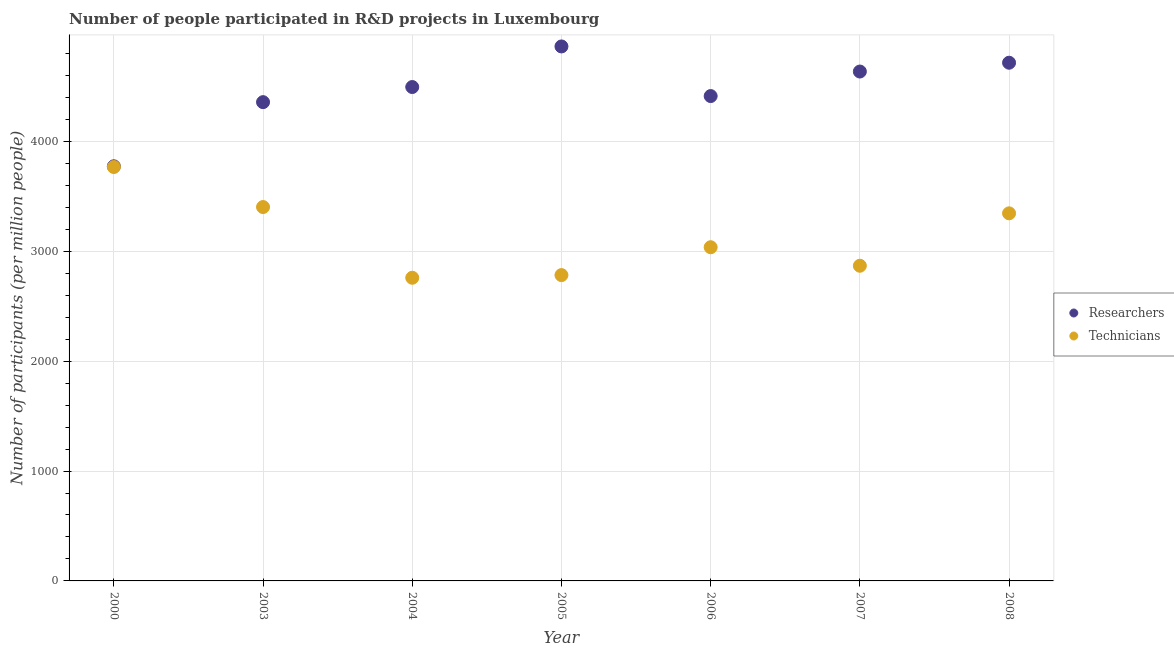What is the number of technicians in 2003?
Provide a short and direct response. 3402.45. Across all years, what is the maximum number of technicians?
Give a very brief answer. 3766.87. Across all years, what is the minimum number of technicians?
Your answer should be compact. 2758.91. In which year was the number of researchers minimum?
Your answer should be very brief. 2000. What is the total number of researchers in the graph?
Provide a short and direct response. 3.13e+04. What is the difference between the number of technicians in 2003 and that in 2008?
Provide a short and direct response. 57.23. What is the difference between the number of technicians in 2004 and the number of researchers in 2008?
Your answer should be very brief. -1957.02. What is the average number of researchers per year?
Offer a very short reply. 4464.75. In the year 2006, what is the difference between the number of researchers and number of technicians?
Keep it short and to the point. 1375.63. In how many years, is the number of researchers greater than 1800?
Provide a succinct answer. 7. What is the ratio of the number of technicians in 2004 to that in 2008?
Ensure brevity in your answer.  0.82. Is the difference between the number of researchers in 2003 and 2007 greater than the difference between the number of technicians in 2003 and 2007?
Provide a short and direct response. No. What is the difference between the highest and the second highest number of technicians?
Offer a very short reply. 364.42. What is the difference between the highest and the lowest number of technicians?
Offer a terse response. 1007.96. Is the sum of the number of researchers in 2003 and 2007 greater than the maximum number of technicians across all years?
Provide a short and direct response. Yes. Does the number of technicians monotonically increase over the years?
Provide a short and direct response. No. How many years are there in the graph?
Your answer should be compact. 7. What is the difference between two consecutive major ticks on the Y-axis?
Provide a succinct answer. 1000. Are the values on the major ticks of Y-axis written in scientific E-notation?
Give a very brief answer. No. Does the graph contain grids?
Provide a short and direct response. Yes. What is the title of the graph?
Your answer should be very brief. Number of people participated in R&D projects in Luxembourg. What is the label or title of the Y-axis?
Offer a very short reply. Number of participants (per million people). What is the Number of participants (per million people) of Researchers in 2000?
Provide a short and direct response. 3773.39. What is the Number of participants (per million people) in Technicians in 2000?
Your response must be concise. 3766.87. What is the Number of participants (per million people) of Researchers in 2003?
Your answer should be compact. 4357.05. What is the Number of participants (per million people) of Technicians in 2003?
Provide a short and direct response. 3402.45. What is the Number of participants (per million people) in Researchers in 2004?
Make the answer very short. 4494.65. What is the Number of participants (per million people) of Technicians in 2004?
Provide a succinct answer. 2758.91. What is the Number of participants (per million people) in Researchers in 2005?
Keep it short and to the point. 4864.07. What is the Number of participants (per million people) in Technicians in 2005?
Offer a very short reply. 2783.2. What is the Number of participants (per million people) in Researchers in 2006?
Provide a succinct answer. 4412.45. What is the Number of participants (per million people) in Technicians in 2006?
Ensure brevity in your answer.  3036.82. What is the Number of participants (per million people) in Researchers in 2007?
Keep it short and to the point. 4635.72. What is the Number of participants (per million people) in Technicians in 2007?
Your answer should be compact. 2868.27. What is the Number of participants (per million people) in Researchers in 2008?
Ensure brevity in your answer.  4715.93. What is the Number of participants (per million people) in Technicians in 2008?
Your answer should be very brief. 3345.22. Across all years, what is the maximum Number of participants (per million people) in Researchers?
Your answer should be very brief. 4864.07. Across all years, what is the maximum Number of participants (per million people) in Technicians?
Offer a very short reply. 3766.87. Across all years, what is the minimum Number of participants (per million people) in Researchers?
Ensure brevity in your answer.  3773.39. Across all years, what is the minimum Number of participants (per million people) of Technicians?
Offer a terse response. 2758.91. What is the total Number of participants (per million people) in Researchers in the graph?
Offer a terse response. 3.13e+04. What is the total Number of participants (per million people) in Technicians in the graph?
Give a very brief answer. 2.20e+04. What is the difference between the Number of participants (per million people) in Researchers in 2000 and that in 2003?
Provide a short and direct response. -583.66. What is the difference between the Number of participants (per million people) of Technicians in 2000 and that in 2003?
Ensure brevity in your answer.  364.42. What is the difference between the Number of participants (per million people) in Researchers in 2000 and that in 2004?
Give a very brief answer. -721.26. What is the difference between the Number of participants (per million people) in Technicians in 2000 and that in 2004?
Give a very brief answer. 1007.96. What is the difference between the Number of participants (per million people) of Researchers in 2000 and that in 2005?
Your answer should be compact. -1090.68. What is the difference between the Number of participants (per million people) of Technicians in 2000 and that in 2005?
Your answer should be compact. 983.67. What is the difference between the Number of participants (per million people) of Researchers in 2000 and that in 2006?
Provide a short and direct response. -639.07. What is the difference between the Number of participants (per million people) of Technicians in 2000 and that in 2006?
Make the answer very short. 730.04. What is the difference between the Number of participants (per million people) in Researchers in 2000 and that in 2007?
Ensure brevity in your answer.  -862.34. What is the difference between the Number of participants (per million people) in Technicians in 2000 and that in 2007?
Your answer should be compact. 898.6. What is the difference between the Number of participants (per million people) of Researchers in 2000 and that in 2008?
Your answer should be compact. -942.55. What is the difference between the Number of participants (per million people) in Technicians in 2000 and that in 2008?
Ensure brevity in your answer.  421.65. What is the difference between the Number of participants (per million people) in Researchers in 2003 and that in 2004?
Keep it short and to the point. -137.6. What is the difference between the Number of participants (per million people) in Technicians in 2003 and that in 2004?
Give a very brief answer. 643.54. What is the difference between the Number of participants (per million people) of Researchers in 2003 and that in 2005?
Make the answer very short. -507.02. What is the difference between the Number of participants (per million people) in Technicians in 2003 and that in 2005?
Ensure brevity in your answer.  619.24. What is the difference between the Number of participants (per million people) of Researchers in 2003 and that in 2006?
Provide a short and direct response. -55.4. What is the difference between the Number of participants (per million people) of Technicians in 2003 and that in 2006?
Ensure brevity in your answer.  365.62. What is the difference between the Number of participants (per million people) of Researchers in 2003 and that in 2007?
Offer a terse response. -278.67. What is the difference between the Number of participants (per million people) in Technicians in 2003 and that in 2007?
Your answer should be very brief. 534.17. What is the difference between the Number of participants (per million people) of Researchers in 2003 and that in 2008?
Ensure brevity in your answer.  -358.88. What is the difference between the Number of participants (per million people) in Technicians in 2003 and that in 2008?
Provide a succinct answer. 57.23. What is the difference between the Number of participants (per million people) in Researchers in 2004 and that in 2005?
Provide a short and direct response. -369.42. What is the difference between the Number of participants (per million people) of Technicians in 2004 and that in 2005?
Keep it short and to the point. -24.29. What is the difference between the Number of participants (per million people) of Researchers in 2004 and that in 2006?
Offer a very short reply. 82.2. What is the difference between the Number of participants (per million people) in Technicians in 2004 and that in 2006?
Give a very brief answer. -277.91. What is the difference between the Number of participants (per million people) in Researchers in 2004 and that in 2007?
Keep it short and to the point. -141.07. What is the difference between the Number of participants (per million people) of Technicians in 2004 and that in 2007?
Your answer should be compact. -109.36. What is the difference between the Number of participants (per million people) in Researchers in 2004 and that in 2008?
Provide a short and direct response. -221.28. What is the difference between the Number of participants (per million people) in Technicians in 2004 and that in 2008?
Keep it short and to the point. -586.31. What is the difference between the Number of participants (per million people) in Researchers in 2005 and that in 2006?
Ensure brevity in your answer.  451.62. What is the difference between the Number of participants (per million people) of Technicians in 2005 and that in 2006?
Your answer should be very brief. -253.62. What is the difference between the Number of participants (per million people) in Researchers in 2005 and that in 2007?
Make the answer very short. 228.35. What is the difference between the Number of participants (per million people) in Technicians in 2005 and that in 2007?
Offer a terse response. -85.07. What is the difference between the Number of participants (per million people) in Researchers in 2005 and that in 2008?
Offer a terse response. 148.14. What is the difference between the Number of participants (per million people) of Technicians in 2005 and that in 2008?
Give a very brief answer. -562.02. What is the difference between the Number of participants (per million people) of Researchers in 2006 and that in 2007?
Your response must be concise. -223.27. What is the difference between the Number of participants (per million people) of Technicians in 2006 and that in 2007?
Keep it short and to the point. 168.55. What is the difference between the Number of participants (per million people) of Researchers in 2006 and that in 2008?
Your answer should be very brief. -303.48. What is the difference between the Number of participants (per million people) of Technicians in 2006 and that in 2008?
Your answer should be very brief. -308.39. What is the difference between the Number of participants (per million people) of Researchers in 2007 and that in 2008?
Your response must be concise. -80.21. What is the difference between the Number of participants (per million people) of Technicians in 2007 and that in 2008?
Keep it short and to the point. -476.95. What is the difference between the Number of participants (per million people) of Researchers in 2000 and the Number of participants (per million people) of Technicians in 2003?
Your response must be concise. 370.94. What is the difference between the Number of participants (per million people) in Researchers in 2000 and the Number of participants (per million people) in Technicians in 2004?
Keep it short and to the point. 1014.47. What is the difference between the Number of participants (per million people) of Researchers in 2000 and the Number of participants (per million people) of Technicians in 2005?
Ensure brevity in your answer.  990.18. What is the difference between the Number of participants (per million people) in Researchers in 2000 and the Number of participants (per million people) in Technicians in 2006?
Make the answer very short. 736.56. What is the difference between the Number of participants (per million people) of Researchers in 2000 and the Number of participants (per million people) of Technicians in 2007?
Your answer should be compact. 905.11. What is the difference between the Number of participants (per million people) in Researchers in 2000 and the Number of participants (per million people) in Technicians in 2008?
Your answer should be very brief. 428.17. What is the difference between the Number of participants (per million people) in Researchers in 2003 and the Number of participants (per million people) in Technicians in 2004?
Provide a succinct answer. 1598.14. What is the difference between the Number of participants (per million people) in Researchers in 2003 and the Number of participants (per million people) in Technicians in 2005?
Offer a terse response. 1573.85. What is the difference between the Number of participants (per million people) in Researchers in 2003 and the Number of participants (per million people) in Technicians in 2006?
Make the answer very short. 1320.23. What is the difference between the Number of participants (per million people) in Researchers in 2003 and the Number of participants (per million people) in Technicians in 2007?
Give a very brief answer. 1488.78. What is the difference between the Number of participants (per million people) of Researchers in 2003 and the Number of participants (per million people) of Technicians in 2008?
Offer a terse response. 1011.83. What is the difference between the Number of participants (per million people) in Researchers in 2004 and the Number of participants (per million people) in Technicians in 2005?
Provide a short and direct response. 1711.45. What is the difference between the Number of participants (per million people) of Researchers in 2004 and the Number of participants (per million people) of Technicians in 2006?
Offer a terse response. 1457.83. What is the difference between the Number of participants (per million people) of Researchers in 2004 and the Number of participants (per million people) of Technicians in 2007?
Provide a short and direct response. 1626.38. What is the difference between the Number of participants (per million people) in Researchers in 2004 and the Number of participants (per million people) in Technicians in 2008?
Make the answer very short. 1149.43. What is the difference between the Number of participants (per million people) of Researchers in 2005 and the Number of participants (per million people) of Technicians in 2006?
Give a very brief answer. 1827.25. What is the difference between the Number of participants (per million people) of Researchers in 2005 and the Number of participants (per million people) of Technicians in 2007?
Your response must be concise. 1995.8. What is the difference between the Number of participants (per million people) in Researchers in 2005 and the Number of participants (per million people) in Technicians in 2008?
Offer a very short reply. 1518.85. What is the difference between the Number of participants (per million people) of Researchers in 2006 and the Number of participants (per million people) of Technicians in 2007?
Ensure brevity in your answer.  1544.18. What is the difference between the Number of participants (per million people) of Researchers in 2006 and the Number of participants (per million people) of Technicians in 2008?
Your response must be concise. 1067.23. What is the difference between the Number of participants (per million people) of Researchers in 2007 and the Number of participants (per million people) of Technicians in 2008?
Your answer should be compact. 1290.5. What is the average Number of participants (per million people) of Researchers per year?
Provide a succinct answer. 4464.75. What is the average Number of participants (per million people) of Technicians per year?
Give a very brief answer. 3137.39. In the year 2000, what is the difference between the Number of participants (per million people) in Researchers and Number of participants (per million people) in Technicians?
Your answer should be very brief. 6.52. In the year 2003, what is the difference between the Number of participants (per million people) in Researchers and Number of participants (per million people) in Technicians?
Your answer should be compact. 954.6. In the year 2004, what is the difference between the Number of participants (per million people) in Researchers and Number of participants (per million people) in Technicians?
Offer a terse response. 1735.74. In the year 2005, what is the difference between the Number of participants (per million people) in Researchers and Number of participants (per million people) in Technicians?
Make the answer very short. 2080.87. In the year 2006, what is the difference between the Number of participants (per million people) of Researchers and Number of participants (per million people) of Technicians?
Provide a short and direct response. 1375.63. In the year 2007, what is the difference between the Number of participants (per million people) in Researchers and Number of participants (per million people) in Technicians?
Your response must be concise. 1767.45. In the year 2008, what is the difference between the Number of participants (per million people) of Researchers and Number of participants (per million people) of Technicians?
Provide a short and direct response. 1370.71. What is the ratio of the Number of participants (per million people) of Researchers in 2000 to that in 2003?
Your answer should be compact. 0.87. What is the ratio of the Number of participants (per million people) of Technicians in 2000 to that in 2003?
Give a very brief answer. 1.11. What is the ratio of the Number of participants (per million people) in Researchers in 2000 to that in 2004?
Keep it short and to the point. 0.84. What is the ratio of the Number of participants (per million people) of Technicians in 2000 to that in 2004?
Your answer should be very brief. 1.37. What is the ratio of the Number of participants (per million people) of Researchers in 2000 to that in 2005?
Offer a very short reply. 0.78. What is the ratio of the Number of participants (per million people) of Technicians in 2000 to that in 2005?
Give a very brief answer. 1.35. What is the ratio of the Number of participants (per million people) in Researchers in 2000 to that in 2006?
Provide a short and direct response. 0.86. What is the ratio of the Number of participants (per million people) in Technicians in 2000 to that in 2006?
Give a very brief answer. 1.24. What is the ratio of the Number of participants (per million people) in Researchers in 2000 to that in 2007?
Provide a short and direct response. 0.81. What is the ratio of the Number of participants (per million people) in Technicians in 2000 to that in 2007?
Offer a very short reply. 1.31. What is the ratio of the Number of participants (per million people) in Researchers in 2000 to that in 2008?
Give a very brief answer. 0.8. What is the ratio of the Number of participants (per million people) in Technicians in 2000 to that in 2008?
Provide a short and direct response. 1.13. What is the ratio of the Number of participants (per million people) in Researchers in 2003 to that in 2004?
Your answer should be compact. 0.97. What is the ratio of the Number of participants (per million people) of Technicians in 2003 to that in 2004?
Make the answer very short. 1.23. What is the ratio of the Number of participants (per million people) in Researchers in 2003 to that in 2005?
Provide a short and direct response. 0.9. What is the ratio of the Number of participants (per million people) in Technicians in 2003 to that in 2005?
Provide a short and direct response. 1.22. What is the ratio of the Number of participants (per million people) of Researchers in 2003 to that in 2006?
Provide a succinct answer. 0.99. What is the ratio of the Number of participants (per million people) of Technicians in 2003 to that in 2006?
Provide a succinct answer. 1.12. What is the ratio of the Number of participants (per million people) of Researchers in 2003 to that in 2007?
Keep it short and to the point. 0.94. What is the ratio of the Number of participants (per million people) in Technicians in 2003 to that in 2007?
Your response must be concise. 1.19. What is the ratio of the Number of participants (per million people) of Researchers in 2003 to that in 2008?
Keep it short and to the point. 0.92. What is the ratio of the Number of participants (per million people) of Technicians in 2003 to that in 2008?
Offer a terse response. 1.02. What is the ratio of the Number of participants (per million people) in Researchers in 2004 to that in 2005?
Your answer should be compact. 0.92. What is the ratio of the Number of participants (per million people) in Technicians in 2004 to that in 2005?
Offer a very short reply. 0.99. What is the ratio of the Number of participants (per million people) of Researchers in 2004 to that in 2006?
Provide a succinct answer. 1.02. What is the ratio of the Number of participants (per million people) in Technicians in 2004 to that in 2006?
Keep it short and to the point. 0.91. What is the ratio of the Number of participants (per million people) in Researchers in 2004 to that in 2007?
Your answer should be very brief. 0.97. What is the ratio of the Number of participants (per million people) of Technicians in 2004 to that in 2007?
Your response must be concise. 0.96. What is the ratio of the Number of participants (per million people) of Researchers in 2004 to that in 2008?
Give a very brief answer. 0.95. What is the ratio of the Number of participants (per million people) of Technicians in 2004 to that in 2008?
Offer a terse response. 0.82. What is the ratio of the Number of participants (per million people) in Researchers in 2005 to that in 2006?
Keep it short and to the point. 1.1. What is the ratio of the Number of participants (per million people) in Technicians in 2005 to that in 2006?
Keep it short and to the point. 0.92. What is the ratio of the Number of participants (per million people) of Researchers in 2005 to that in 2007?
Give a very brief answer. 1.05. What is the ratio of the Number of participants (per million people) in Technicians in 2005 to that in 2007?
Ensure brevity in your answer.  0.97. What is the ratio of the Number of participants (per million people) in Researchers in 2005 to that in 2008?
Provide a short and direct response. 1.03. What is the ratio of the Number of participants (per million people) of Technicians in 2005 to that in 2008?
Your answer should be very brief. 0.83. What is the ratio of the Number of participants (per million people) of Researchers in 2006 to that in 2007?
Your answer should be very brief. 0.95. What is the ratio of the Number of participants (per million people) of Technicians in 2006 to that in 2007?
Your response must be concise. 1.06. What is the ratio of the Number of participants (per million people) in Researchers in 2006 to that in 2008?
Your answer should be compact. 0.94. What is the ratio of the Number of participants (per million people) in Technicians in 2006 to that in 2008?
Keep it short and to the point. 0.91. What is the ratio of the Number of participants (per million people) in Researchers in 2007 to that in 2008?
Provide a short and direct response. 0.98. What is the ratio of the Number of participants (per million people) in Technicians in 2007 to that in 2008?
Offer a very short reply. 0.86. What is the difference between the highest and the second highest Number of participants (per million people) of Researchers?
Offer a terse response. 148.14. What is the difference between the highest and the second highest Number of participants (per million people) of Technicians?
Keep it short and to the point. 364.42. What is the difference between the highest and the lowest Number of participants (per million people) of Researchers?
Give a very brief answer. 1090.68. What is the difference between the highest and the lowest Number of participants (per million people) of Technicians?
Your response must be concise. 1007.96. 